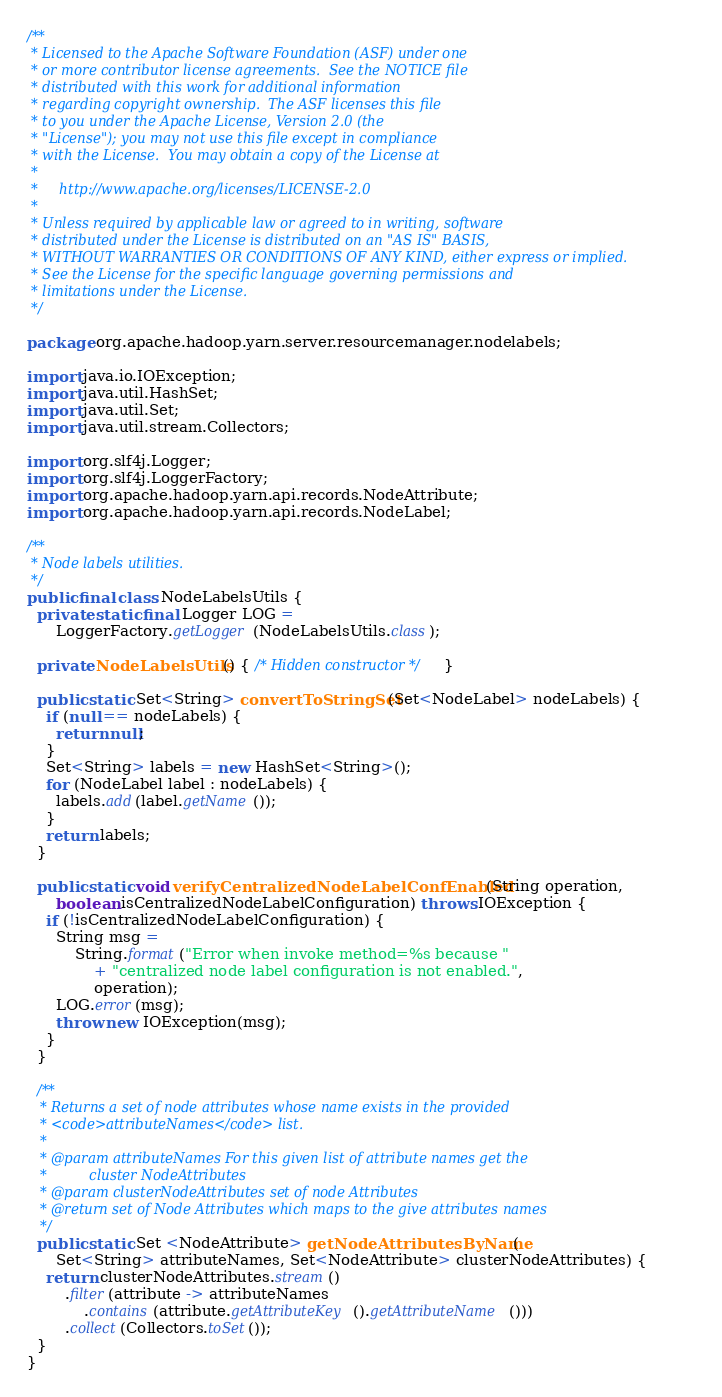Convert code to text. <code><loc_0><loc_0><loc_500><loc_500><_Java_>/**
 * Licensed to the Apache Software Foundation (ASF) under one
 * or more contributor license agreements.  See the NOTICE file
 * distributed with this work for additional information
 * regarding copyright ownership.  The ASF licenses this file
 * to you under the Apache License, Version 2.0 (the
 * "License"); you may not use this file except in compliance
 * with the License.  You may obtain a copy of the License at
 *
 *     http://www.apache.org/licenses/LICENSE-2.0
 *
 * Unless required by applicable law or agreed to in writing, software
 * distributed under the License is distributed on an "AS IS" BASIS,
 * WITHOUT WARRANTIES OR CONDITIONS OF ANY KIND, either express or implied.
 * See the License for the specific language governing permissions and
 * limitations under the License.
 */

package org.apache.hadoop.yarn.server.resourcemanager.nodelabels;

import java.io.IOException;
import java.util.HashSet;
import java.util.Set;
import java.util.stream.Collectors;

import org.slf4j.Logger;
import org.slf4j.LoggerFactory;
import org.apache.hadoop.yarn.api.records.NodeAttribute;
import org.apache.hadoop.yarn.api.records.NodeLabel;

/**
 * Node labels utilities.
 */
public final class NodeLabelsUtils {
  private static final Logger LOG =
      LoggerFactory.getLogger(NodeLabelsUtils.class);

  private NodeLabelsUtils() { /* Hidden constructor */ }

  public static Set<String> convertToStringSet(Set<NodeLabel> nodeLabels) {
    if (null == nodeLabels) {
      return null;
    }
    Set<String> labels = new HashSet<String>();
    for (NodeLabel label : nodeLabels) {
      labels.add(label.getName());
    }
    return labels;
  }

  public static void verifyCentralizedNodeLabelConfEnabled(String operation,
      boolean isCentralizedNodeLabelConfiguration) throws IOException {
    if (!isCentralizedNodeLabelConfiguration) {
      String msg =
          String.format("Error when invoke method=%s because "
              + "centralized node label configuration is not enabled.",
              operation);
      LOG.error(msg);
      throw new IOException(msg);
    }
  }

  /**
   * Returns a set of node attributes whose name exists in the provided
   * <code>attributeNames</code> list.
   *
   * @param attributeNames For this given list of attribute names get the
   *          cluster NodeAttributes
   * @param clusterNodeAttributes set of node Attributes
   * @return set of Node Attributes which maps to the give attributes names
   */
  public static Set <NodeAttribute> getNodeAttributesByName(
      Set<String> attributeNames, Set<NodeAttribute> clusterNodeAttributes) {
    return clusterNodeAttributes.stream()
        .filter(attribute -> attributeNames
            .contains(attribute.getAttributeKey().getAttributeName()))
        .collect(Collectors.toSet());
  }
}
</code> 